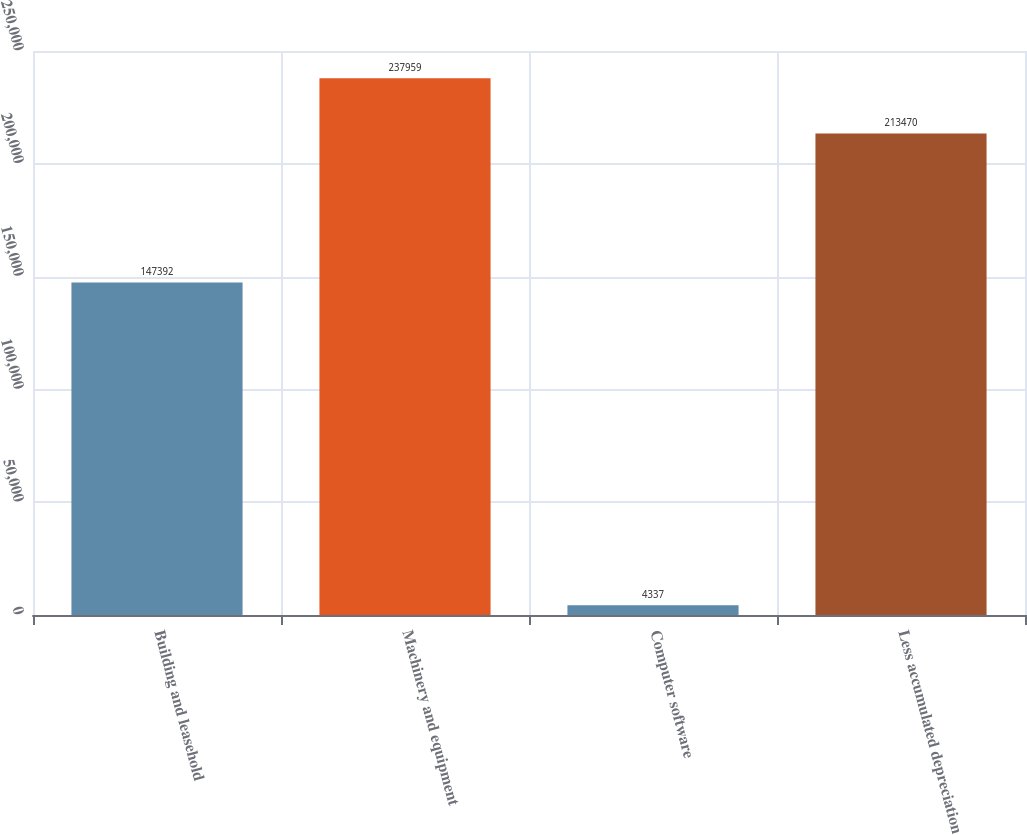Convert chart. <chart><loc_0><loc_0><loc_500><loc_500><bar_chart><fcel>Building and leasehold<fcel>Machinery and equipment<fcel>Computer software<fcel>Less accumulated depreciation<nl><fcel>147392<fcel>237959<fcel>4337<fcel>213470<nl></chart> 